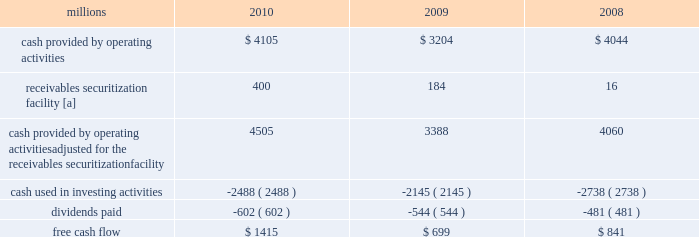2009 levels , we returned a portion of these assets to active service .
At the end of 2010 , we continued to maintain in storage approximately 17% ( 17 % ) of our multiple purpose locomotives and 14% ( 14 % ) of our freight car inventory , reflecting our ability to effectively leverage our assets as volumes return to our network .
2022 fuel prices 2013 fuel prices generally increased throughout 2010 as the economy improved .
Our average diesel fuel price per gallon increased nearly 20% ( 20 % ) from january to december of 2010 , driven by higher crude oil barrel prices and conversion spreads .
Compared to 2009 , our diesel fuel price per gallon consumed increased 31% ( 31 % ) , driving operating expenses up by $ 566 million ( excluding any impact from year-over-year volume increases ) .
To partially offset the effect of higher fuel prices , we reduced our consumption rate by 3% ( 3 % ) during the year , saving approximately 27 million gallons of fuel .
The use of newer , more fuel efficient locomotives ; increased use of distributed locomotive power ( the practice of distributing locomotives throughout a train rather than positioning them all in the lead resulting in safer and more efficient train operations ) ; fuel conservation programs ; and efficient network operations and asset utilization all contributed to this improvement .
2022 free cash flow 2013 cash generated by operating activities ( adjusted for the reclassification of our receivables securitization facility ) totaled $ 4.5 billion , yielding record free cash flow of $ 1.4 billion in 2010 .
Free cash flow is defined as cash provided by operating activities ( adjusted for the reclassification of our receivables securitization facility ) , less cash used in investing activities and dividends paid .
Free cash flow is not considered a financial measure under accounting principles generally accepted in the u.s .
( gaap ) by sec regulation g and item 10 of sec regulation s-k .
We believe free cash flow is important in evaluating our financial performance and measures our ability to generate cash without additional external financings .
Free cash flow should be considered in addition to , rather than as a substitute for , cash provided by operating activities .
The table reconciles cash provided by operating activities ( gaap measure ) to free cash flow ( non-gaap measure ) : millions 2010 2009 2008 .
[a] effective january 1 , 2010 , a new accounting standard required us to account for receivables transferred under our receivables securitization facility as secured borrowings in our consolidated statements of financial position and as financing activities in our consolidated statements of cash flows .
The receivables securitization facility is included in our free cash flow calculation to adjust cash provided by operating activities as though our receivables securitization facility had been accounted for under the new accounting standard for all periods presented .
2011 outlook 2022 safety 2013 operating a safe railroad benefits our employees , our customers , our shareholders , and the public .
We will continue using a multi-faceted approach to safety , utilizing technology , risk assessment , quality control , and training , and engaging our employees .
We will continue implementing total safety culture ( tsc ) throughout our operations .
Tsc is designed to establish , maintain , reinforce , and promote safe practices among co-workers .
This process allows us to identify and implement best practices for employee and operational safety .
Reducing grade crossing incidents is a critical aspect of our safety programs , and we will continue our efforts to maintain and close crossings ; install video cameras on locomotives ; and educate the public and law enforcement agencies about crossing safety through a combination of our own programs ( including risk assessment strategies ) , various industry programs , and engaging local communities .
2022 transportation plan 2013 to build upon our success in recent years , we will continue evaluating traffic flows and network logistic patterns , which can be quite dynamic , to identify additional opportunities to simplify operations , remove network variability , and improve network efficiency and asset utilization .
We plan to adjust manpower and our locomotive and rail car fleets to meet customer needs and put .
What is the annual average dividend paid from 2008-2010 , in millions? 
Computations: (((602 + 544) + 481) / 3)
Answer: 542.33333. 